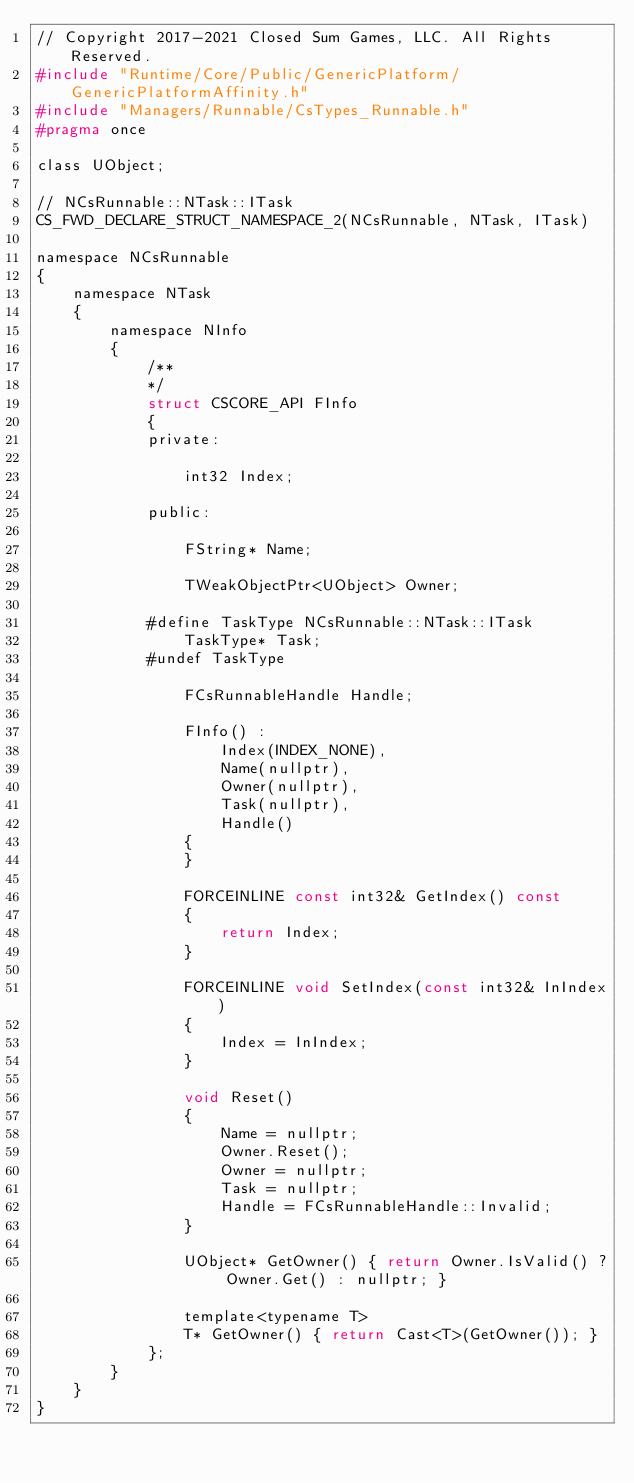<code> <loc_0><loc_0><loc_500><loc_500><_C_>// Copyright 2017-2021 Closed Sum Games, LLC. All Rights Reserved.
#include "Runtime/Core/Public/GenericPlatform/GenericPlatformAffinity.h"
#include "Managers/Runnable/CsTypes_Runnable.h"
#pragma once

class UObject;

// NCsRunnable::NTask::ITask
CS_FWD_DECLARE_STRUCT_NAMESPACE_2(NCsRunnable, NTask, ITask)

namespace NCsRunnable
{
	namespace NTask
	{
		namespace NInfo
		{
			/**
			*/
			struct CSCORE_API FInfo
			{
			private:

				int32 Index;

			public:

				FString* Name;

				TWeakObjectPtr<UObject> Owner;

			#define TaskType NCsRunnable::NTask::ITask
				TaskType* Task;
			#undef TaskType

				FCsRunnableHandle Handle;

				FInfo() :
					Index(INDEX_NONE),
					Name(nullptr),
					Owner(nullptr),
					Task(nullptr),
					Handle()
				{
				}

				FORCEINLINE const int32& GetIndex() const
				{
					return Index;
				}

				FORCEINLINE void SetIndex(const int32& InIndex)
				{
					Index = InIndex;
				}

				void Reset()
				{
					Name = nullptr;
					Owner.Reset();
					Owner = nullptr;
					Task = nullptr;
					Handle = FCsRunnableHandle::Invalid;
				}

				UObject* GetOwner() { return Owner.IsValid() ? Owner.Get() : nullptr; }
	
				template<typename T>
				T* GetOwner() { return Cast<T>(GetOwner()); }
			};
		}
	}
}</code> 